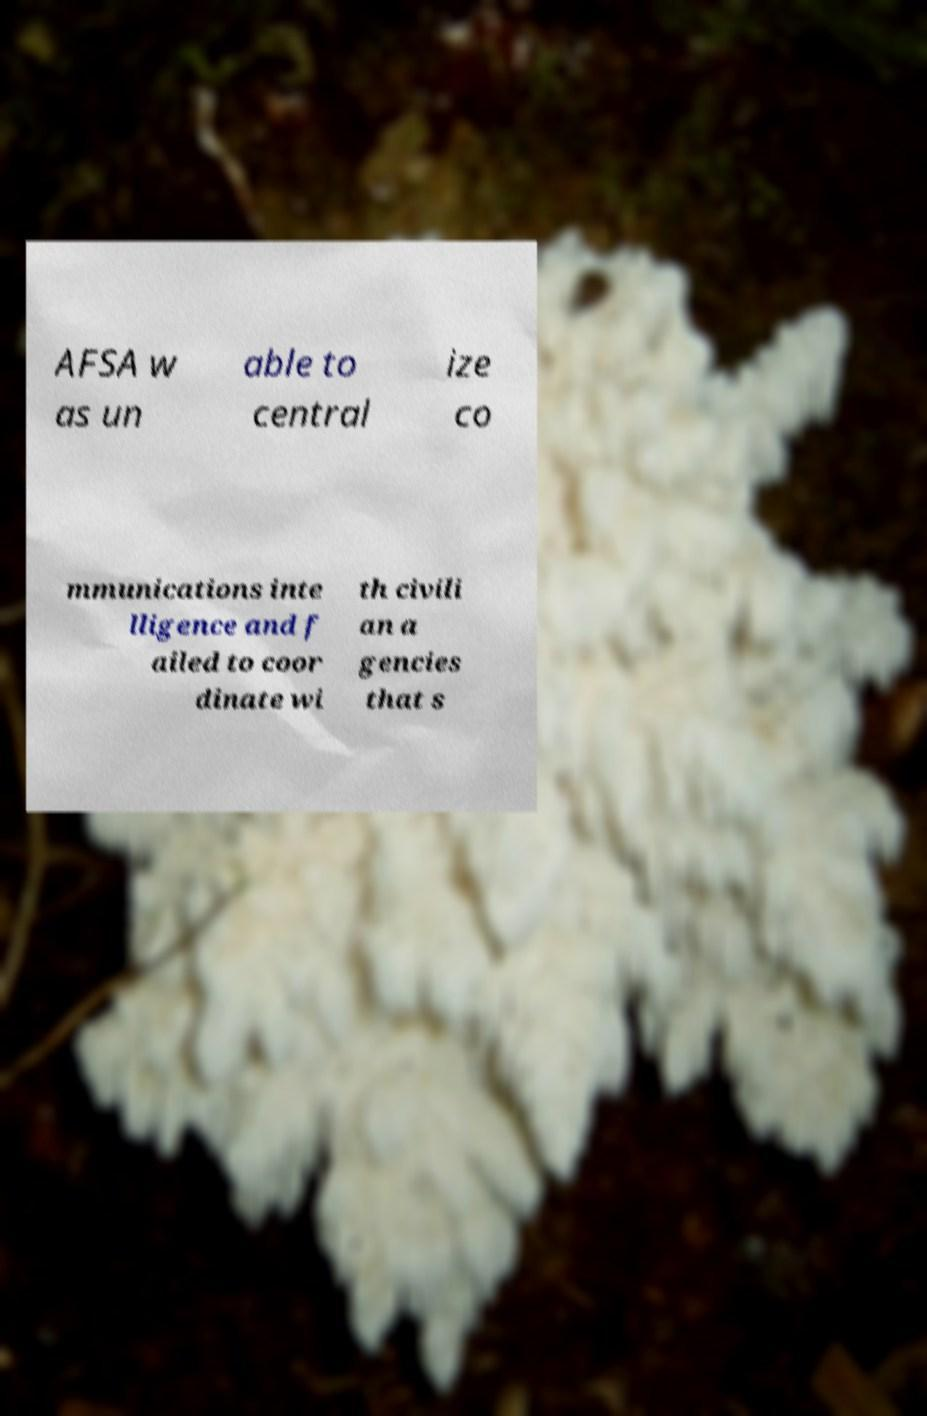Could you extract and type out the text from this image? AFSA w as un able to central ize co mmunications inte lligence and f ailed to coor dinate wi th civili an a gencies that s 